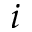Convert formula to latex. <formula><loc_0><loc_0><loc_500><loc_500>i</formula> 